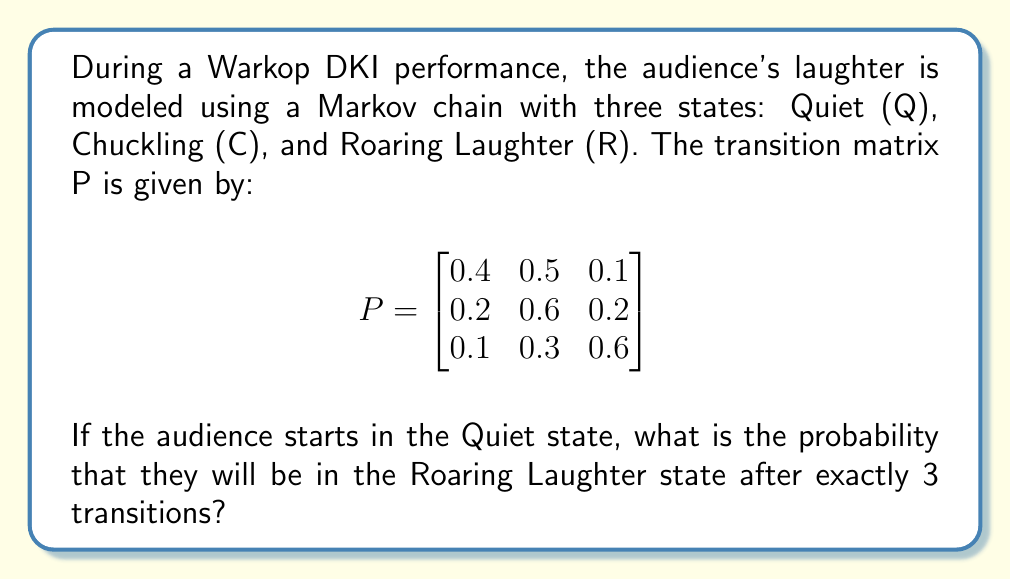Give your solution to this math problem. To solve this problem, we need to calculate the 3-step transition probability from the Quiet state (Q) to the Roaring Laughter state (R). We can do this by raising the transition matrix P to the power of 3 and then looking at the entry in the first row, third column.

Step 1: Calculate $P^3$
$$P^3 = P \times P \times P$$

We can use matrix multiplication to compute this:

$$P^2 = \begin{bmatrix}
0.4 & 0.5 & 0.1 \\
0.2 & 0.6 & 0.2 \\
0.1 & 0.3 & 0.6
\end{bmatrix} \times \begin{bmatrix}
0.4 & 0.5 & 0.1 \\
0.2 & 0.6 & 0.2 \\
0.1 & 0.3 & 0.6
\end{bmatrix} = \begin{bmatrix}
0.30 & 0.53 & 0.17 \\
0.26 & 0.54 & 0.20 \\
0.19 & 0.42 & 0.39
\end{bmatrix}$$

Now, we multiply $P^2$ by P:

$$P^3 = \begin{bmatrix}
0.30 & 0.53 & 0.17 \\
0.26 & 0.54 & 0.20 \\
0.19 & 0.42 & 0.39
\end{bmatrix} \times \begin{bmatrix}
0.4 & 0.5 & 0.1 \\
0.2 & 0.6 & 0.2 \\
0.1 & 0.3 & 0.6
\end{bmatrix} = \begin{bmatrix}
0.263 & 0.521 & 0.216 \\
0.250 & 0.522 & 0.228 \\
0.211 & 0.459 & 0.330
\end{bmatrix}$$

Step 2: Identify the required probability
The probability of being in the Roaring Laughter state (R) after 3 transitions, starting from the Quiet state (Q), is the entry in the first row and third column of $P^3$.

This value is 0.216 or 21.6%.
Answer: 0.216 